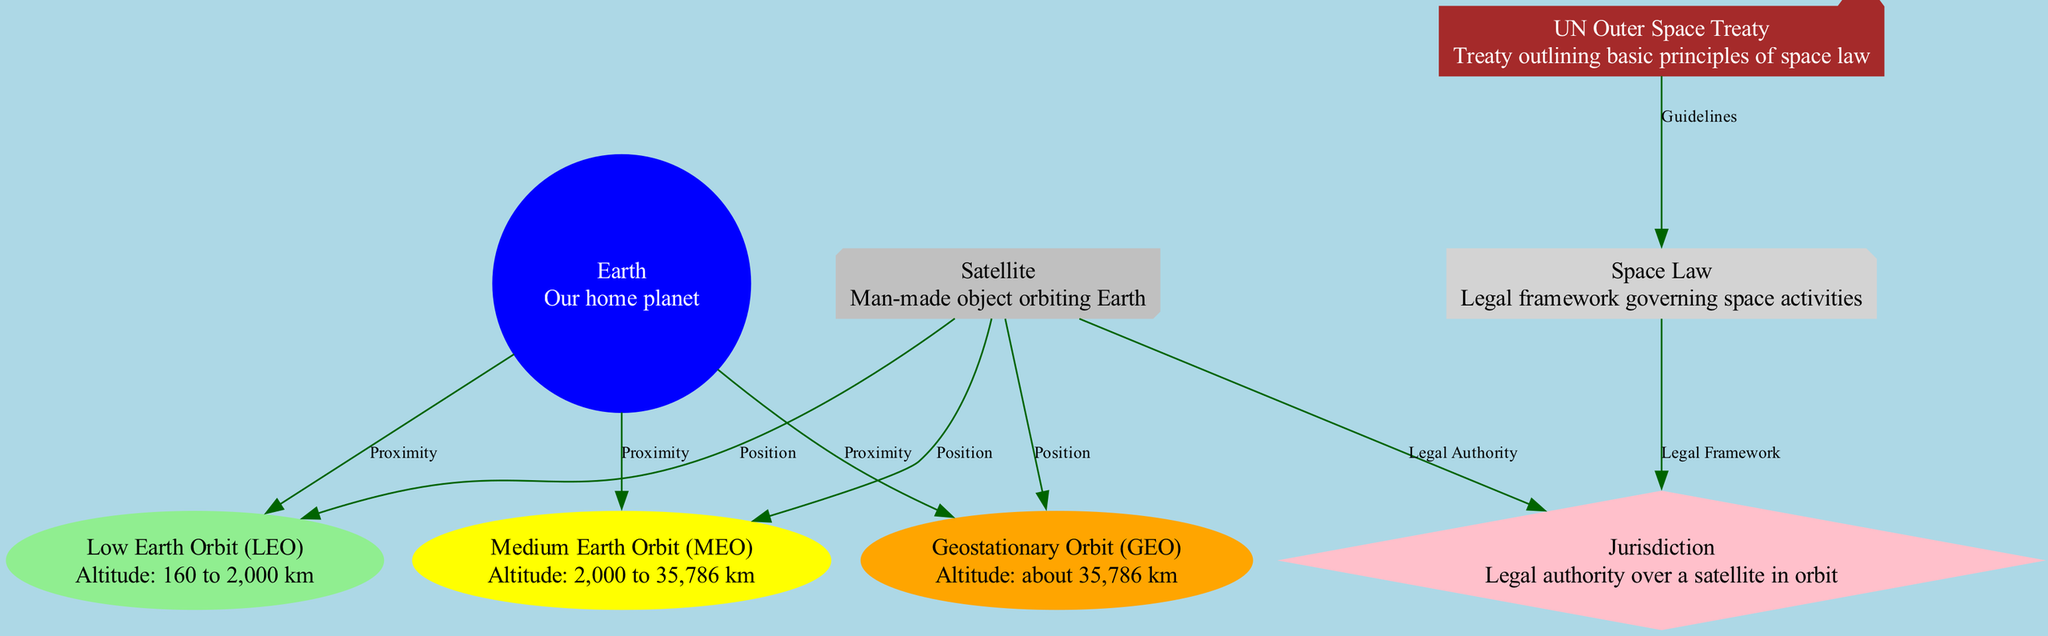What is the highest altitude orbit listed in the diagram? The diagram identifies the three orbits: Low Earth Orbit, Medium Earth Orbit, and Geostationary Orbit. Among these, Geostationary Orbit has an altitude of about 35,786 km, which is the highest value mentioned.
Answer: Geostationary Orbit What legal framework governs space activities according to the diagram? According to the diagram, "Space Law" is the legal framework that governs space activities, as indicated by the connection from Space Law to Jurisdiction.
Answer: Space Law How many types of orbits are represented in the diagram? The diagram shows three types of orbits: Low Earth Orbit, Medium Earth Orbit, and Geostationary Orbit. Each of these orbits is distinctly represented in the nodes.
Answer: Three What is the main legal authority over a satellite in orbit according to the diagram? The diagram states that Jurisdiction is the legal authority over a satellite in orbit, as it directly connects the Satellite node to the Jurisdiction node.
Answer: Jurisdiction Which treaty outlines basic principles of space law? The UN Outer Space Treaty is mentioned in the diagram as the treaty that outlines basic principles of space law, connected to the Space Law node.
Answer: UN Outer Space Treaty Which orbit is the closest proximity to Earth? The diagram links Earth to Low Earth Orbit, indicating that Low Earth Orbit is the closest in proximity to Earth among the three types of orbits depicted.
Answer: Low Earth Orbit What connects the UN Outer Space Treaty to Space Law in the diagram? The diagram shows a connection labeled "Guidelines" that directly links the UN Outer Space Treaty node to the Space Law node, indicating the treaty guides the framework for space law.
Answer: Guidelines What color represents the Medium Earth Orbit in the diagram? The Medium Earth Orbit node is styled with a yellow color, making it distinctive from other orbits represented in the diagram.
Answer: Yellow How is the relationship between Satellites and their position in Low Earth Orbit described? The diagram indicates that there is a connection from the Satellite node to Low Earth Orbit labeled "Position," showing that satellites occupy this orbital location.
Answer: Position 